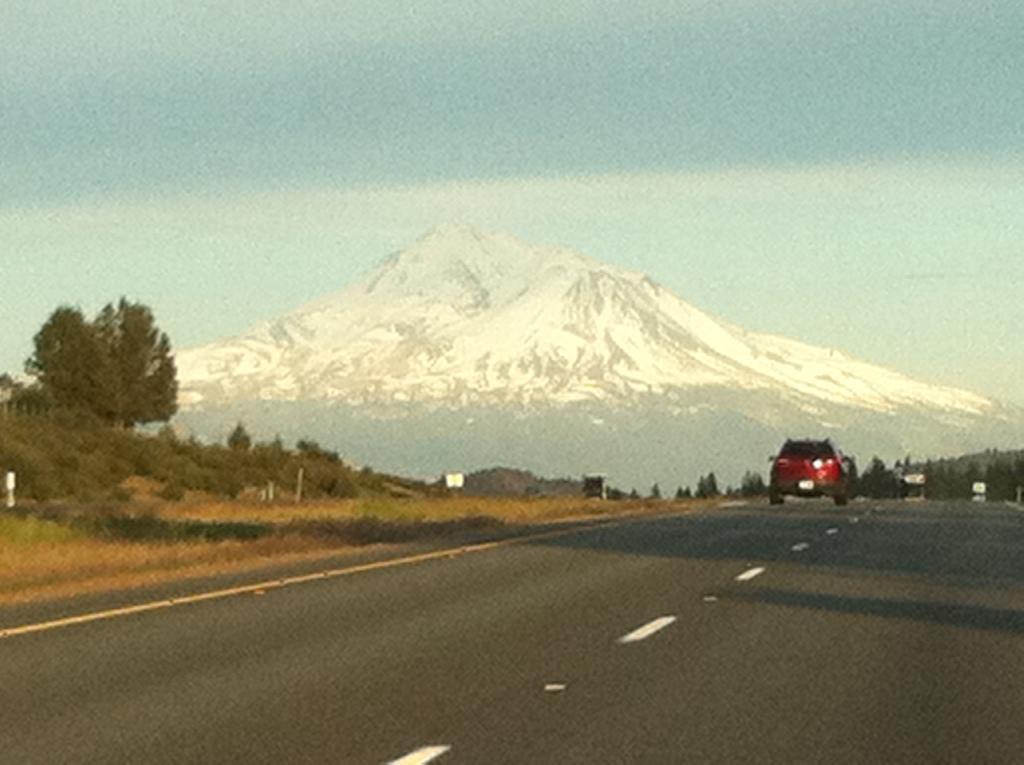Describe this image in one or two sentences. In this image we can see a car on the road. On the left there are trees. In the background there are hills and sky. 